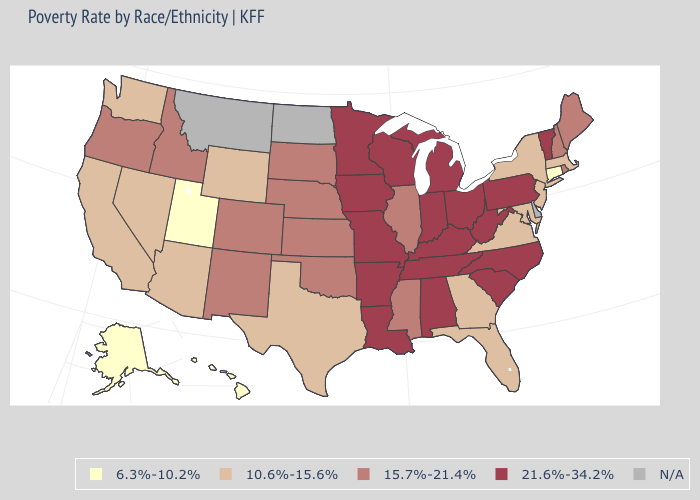Among the states that border Washington , which have the lowest value?
Concise answer only. Idaho, Oregon. Name the states that have a value in the range N/A?
Concise answer only. Delaware, Montana, North Dakota. Which states have the highest value in the USA?
Concise answer only. Alabama, Arkansas, Indiana, Iowa, Kentucky, Louisiana, Michigan, Minnesota, Missouri, North Carolina, Ohio, Pennsylvania, South Carolina, Tennessee, Vermont, West Virginia, Wisconsin. What is the lowest value in the USA?
Short answer required. 6.3%-10.2%. Does the first symbol in the legend represent the smallest category?
Keep it brief. Yes. Name the states that have a value in the range 10.6%-15.6%?
Write a very short answer. Arizona, California, Florida, Georgia, Maryland, Massachusetts, Nevada, New Jersey, New York, Texas, Virginia, Washington, Wyoming. What is the value of Arkansas?
Short answer required. 21.6%-34.2%. What is the value of Montana?
Keep it brief. N/A. What is the lowest value in the USA?
Quick response, please. 6.3%-10.2%. What is the highest value in the USA?
Short answer required. 21.6%-34.2%. Name the states that have a value in the range 21.6%-34.2%?
Be succinct. Alabama, Arkansas, Indiana, Iowa, Kentucky, Louisiana, Michigan, Minnesota, Missouri, North Carolina, Ohio, Pennsylvania, South Carolina, Tennessee, Vermont, West Virginia, Wisconsin. Name the states that have a value in the range 10.6%-15.6%?
Answer briefly. Arizona, California, Florida, Georgia, Maryland, Massachusetts, Nevada, New Jersey, New York, Texas, Virginia, Washington, Wyoming. Name the states that have a value in the range 10.6%-15.6%?
Short answer required. Arizona, California, Florida, Georgia, Maryland, Massachusetts, Nevada, New Jersey, New York, Texas, Virginia, Washington, Wyoming. How many symbols are there in the legend?
Short answer required. 5. Does Vermont have the highest value in the Northeast?
Keep it brief. Yes. 